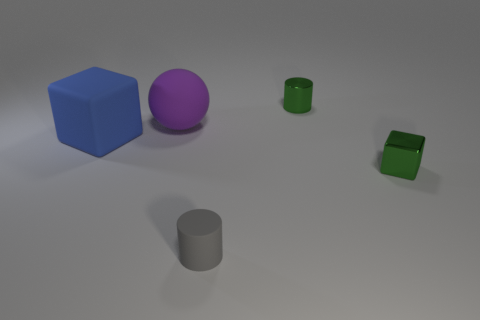How many things are either objects on the right side of the big matte sphere or small red objects?
Your response must be concise. 3. Are there any large matte objects of the same color as the small metallic cylinder?
Keep it short and to the point. No. There is a tiny gray thing; is it the same shape as the shiny object on the left side of the small green block?
Your answer should be very brief. Yes. What number of rubber objects are behind the blue cube and on the right side of the ball?
Keep it short and to the point. 0. There is a tiny green thing that is the same shape as the gray thing; what material is it?
Give a very brief answer. Metal. What size is the green object behind the small shiny object that is right of the shiny cylinder?
Your answer should be compact. Small. Is there a big green block?
Your response must be concise. No. What is the object that is both in front of the large purple matte object and on the right side of the tiny gray rubber thing made of?
Keep it short and to the point. Metal. Is the number of matte things that are in front of the small cube greater than the number of large matte balls that are behind the big purple rubber ball?
Your answer should be compact. Yes. Is there a rubber cylinder that has the same size as the gray rubber object?
Offer a very short reply. No. 